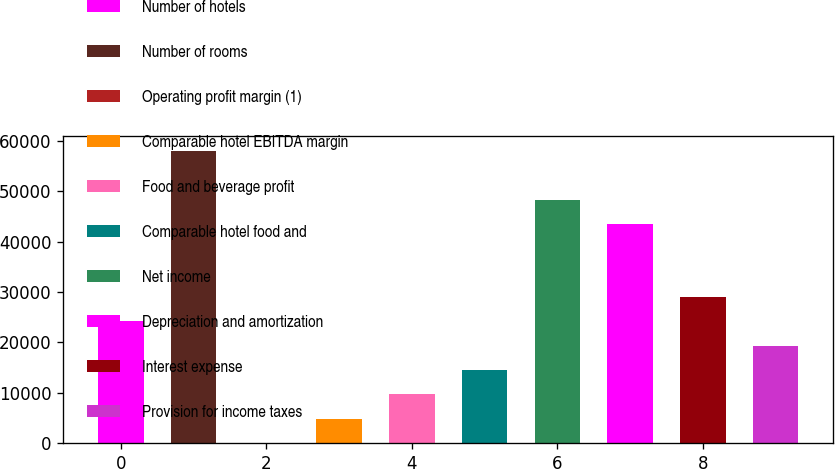<chart> <loc_0><loc_0><loc_500><loc_500><bar_chart><fcel>Number of hotels<fcel>Number of rooms<fcel>Operating profit margin (1)<fcel>Comparable hotel EBITDA margin<fcel>Food and beverage profit<fcel>Comparable hotel food and<fcel>Net income<fcel>Depreciation and amortization<fcel>Interest expense<fcel>Provision for income taxes<nl><fcel>24184.8<fcel>58025.9<fcel>12.6<fcel>4847.04<fcel>9681.48<fcel>14515.9<fcel>48357<fcel>43522.6<fcel>29019.2<fcel>19350.4<nl></chart> 